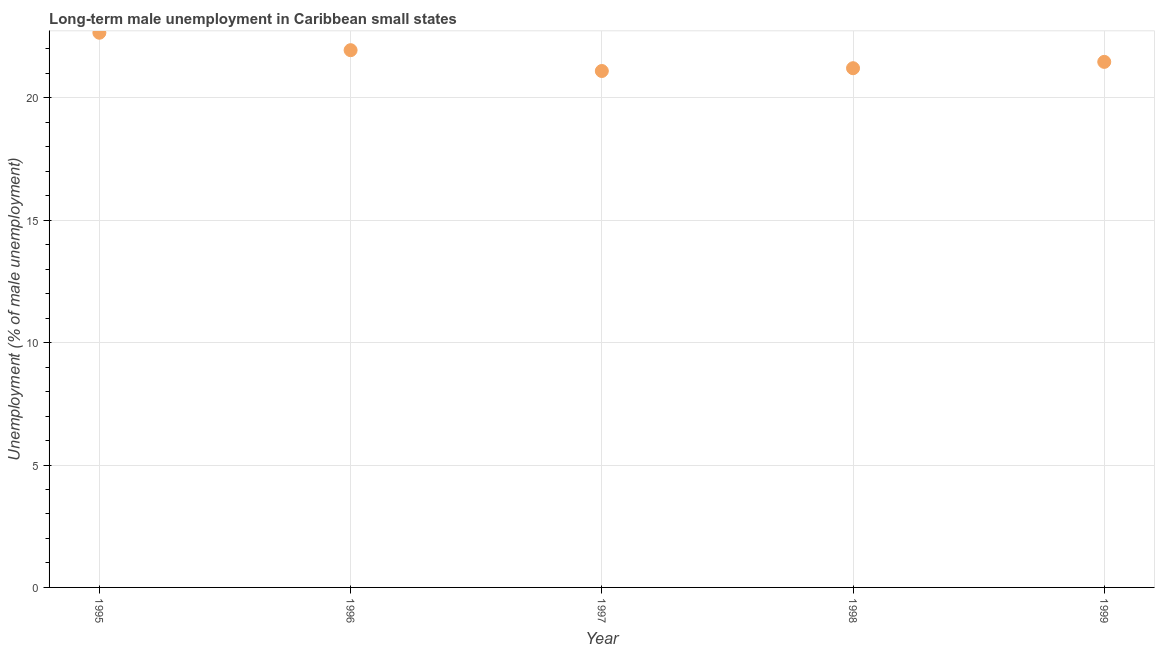What is the long-term male unemployment in 1996?
Provide a succinct answer. 21.95. Across all years, what is the maximum long-term male unemployment?
Offer a very short reply. 22.66. Across all years, what is the minimum long-term male unemployment?
Offer a terse response. 21.1. In which year was the long-term male unemployment maximum?
Ensure brevity in your answer.  1995. What is the sum of the long-term male unemployment?
Ensure brevity in your answer.  108.39. What is the difference between the long-term male unemployment in 1996 and 1999?
Your answer should be very brief. 0.48. What is the average long-term male unemployment per year?
Offer a very short reply. 21.68. What is the median long-term male unemployment?
Your answer should be very brief. 21.47. In how many years, is the long-term male unemployment greater than 2 %?
Make the answer very short. 5. What is the ratio of the long-term male unemployment in 1996 to that in 1998?
Your answer should be compact. 1.03. What is the difference between the highest and the second highest long-term male unemployment?
Keep it short and to the point. 0.71. Is the sum of the long-term male unemployment in 1996 and 1999 greater than the maximum long-term male unemployment across all years?
Provide a succinct answer. Yes. What is the difference between the highest and the lowest long-term male unemployment?
Offer a terse response. 1.56. Does the long-term male unemployment monotonically increase over the years?
Offer a very short reply. No. How many dotlines are there?
Provide a short and direct response. 1. How many years are there in the graph?
Make the answer very short. 5. What is the difference between two consecutive major ticks on the Y-axis?
Your answer should be compact. 5. Are the values on the major ticks of Y-axis written in scientific E-notation?
Provide a succinct answer. No. Does the graph contain any zero values?
Offer a very short reply. No. Does the graph contain grids?
Provide a succinct answer. Yes. What is the title of the graph?
Offer a terse response. Long-term male unemployment in Caribbean small states. What is the label or title of the Y-axis?
Give a very brief answer. Unemployment (% of male unemployment). What is the Unemployment (% of male unemployment) in 1995?
Ensure brevity in your answer.  22.66. What is the Unemployment (% of male unemployment) in 1996?
Provide a short and direct response. 21.95. What is the Unemployment (% of male unemployment) in 1997?
Provide a succinct answer. 21.1. What is the Unemployment (% of male unemployment) in 1998?
Your answer should be compact. 21.21. What is the Unemployment (% of male unemployment) in 1999?
Offer a terse response. 21.47. What is the difference between the Unemployment (% of male unemployment) in 1995 and 1996?
Provide a succinct answer. 0.71. What is the difference between the Unemployment (% of male unemployment) in 1995 and 1997?
Keep it short and to the point. 1.56. What is the difference between the Unemployment (% of male unemployment) in 1995 and 1998?
Your answer should be compact. 1.45. What is the difference between the Unemployment (% of male unemployment) in 1995 and 1999?
Your response must be concise. 1.19. What is the difference between the Unemployment (% of male unemployment) in 1996 and 1997?
Offer a terse response. 0.85. What is the difference between the Unemployment (% of male unemployment) in 1996 and 1998?
Ensure brevity in your answer.  0.74. What is the difference between the Unemployment (% of male unemployment) in 1996 and 1999?
Your response must be concise. 0.48. What is the difference between the Unemployment (% of male unemployment) in 1997 and 1998?
Provide a succinct answer. -0.11. What is the difference between the Unemployment (% of male unemployment) in 1997 and 1999?
Keep it short and to the point. -0.37. What is the difference between the Unemployment (% of male unemployment) in 1998 and 1999?
Ensure brevity in your answer.  -0.26. What is the ratio of the Unemployment (% of male unemployment) in 1995 to that in 1996?
Offer a very short reply. 1.03. What is the ratio of the Unemployment (% of male unemployment) in 1995 to that in 1997?
Your answer should be compact. 1.07. What is the ratio of the Unemployment (% of male unemployment) in 1995 to that in 1998?
Offer a very short reply. 1.07. What is the ratio of the Unemployment (% of male unemployment) in 1995 to that in 1999?
Offer a terse response. 1.05. What is the ratio of the Unemployment (% of male unemployment) in 1996 to that in 1997?
Offer a very short reply. 1.04. What is the ratio of the Unemployment (% of male unemployment) in 1996 to that in 1998?
Your response must be concise. 1.03. What is the ratio of the Unemployment (% of male unemployment) in 1997 to that in 1999?
Provide a short and direct response. 0.98. What is the ratio of the Unemployment (% of male unemployment) in 1998 to that in 1999?
Keep it short and to the point. 0.99. 